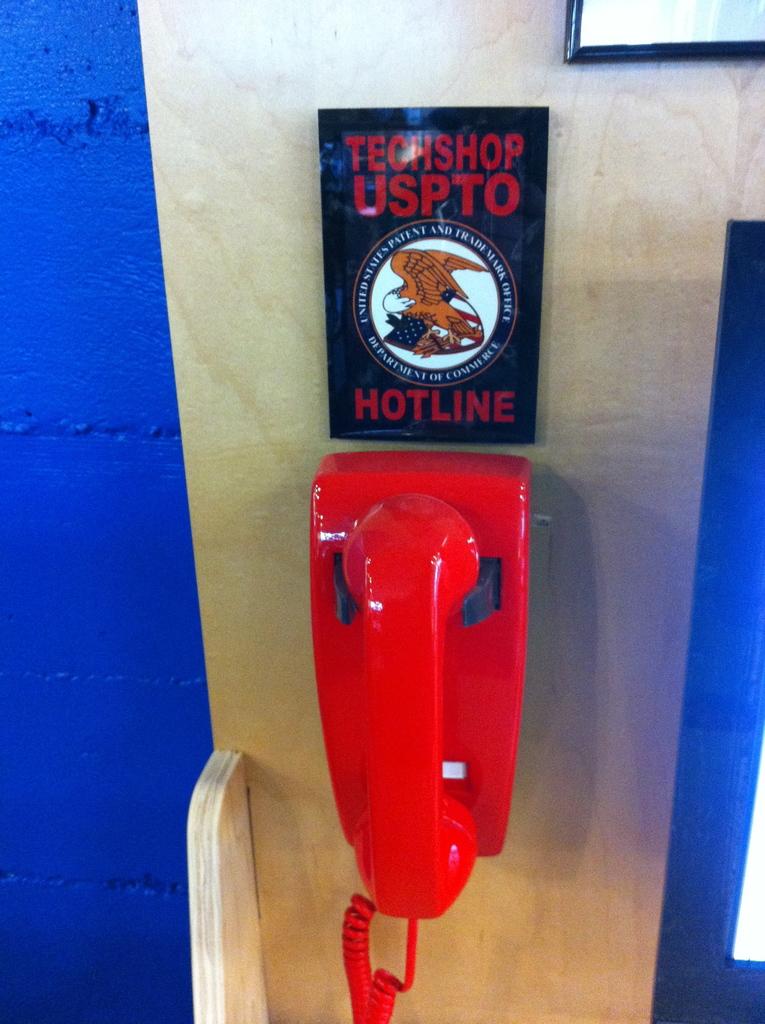What type of hotline is this?
Offer a terse response. Techshop uspto. What word appears above the line?
Keep it short and to the point. Hotline. 